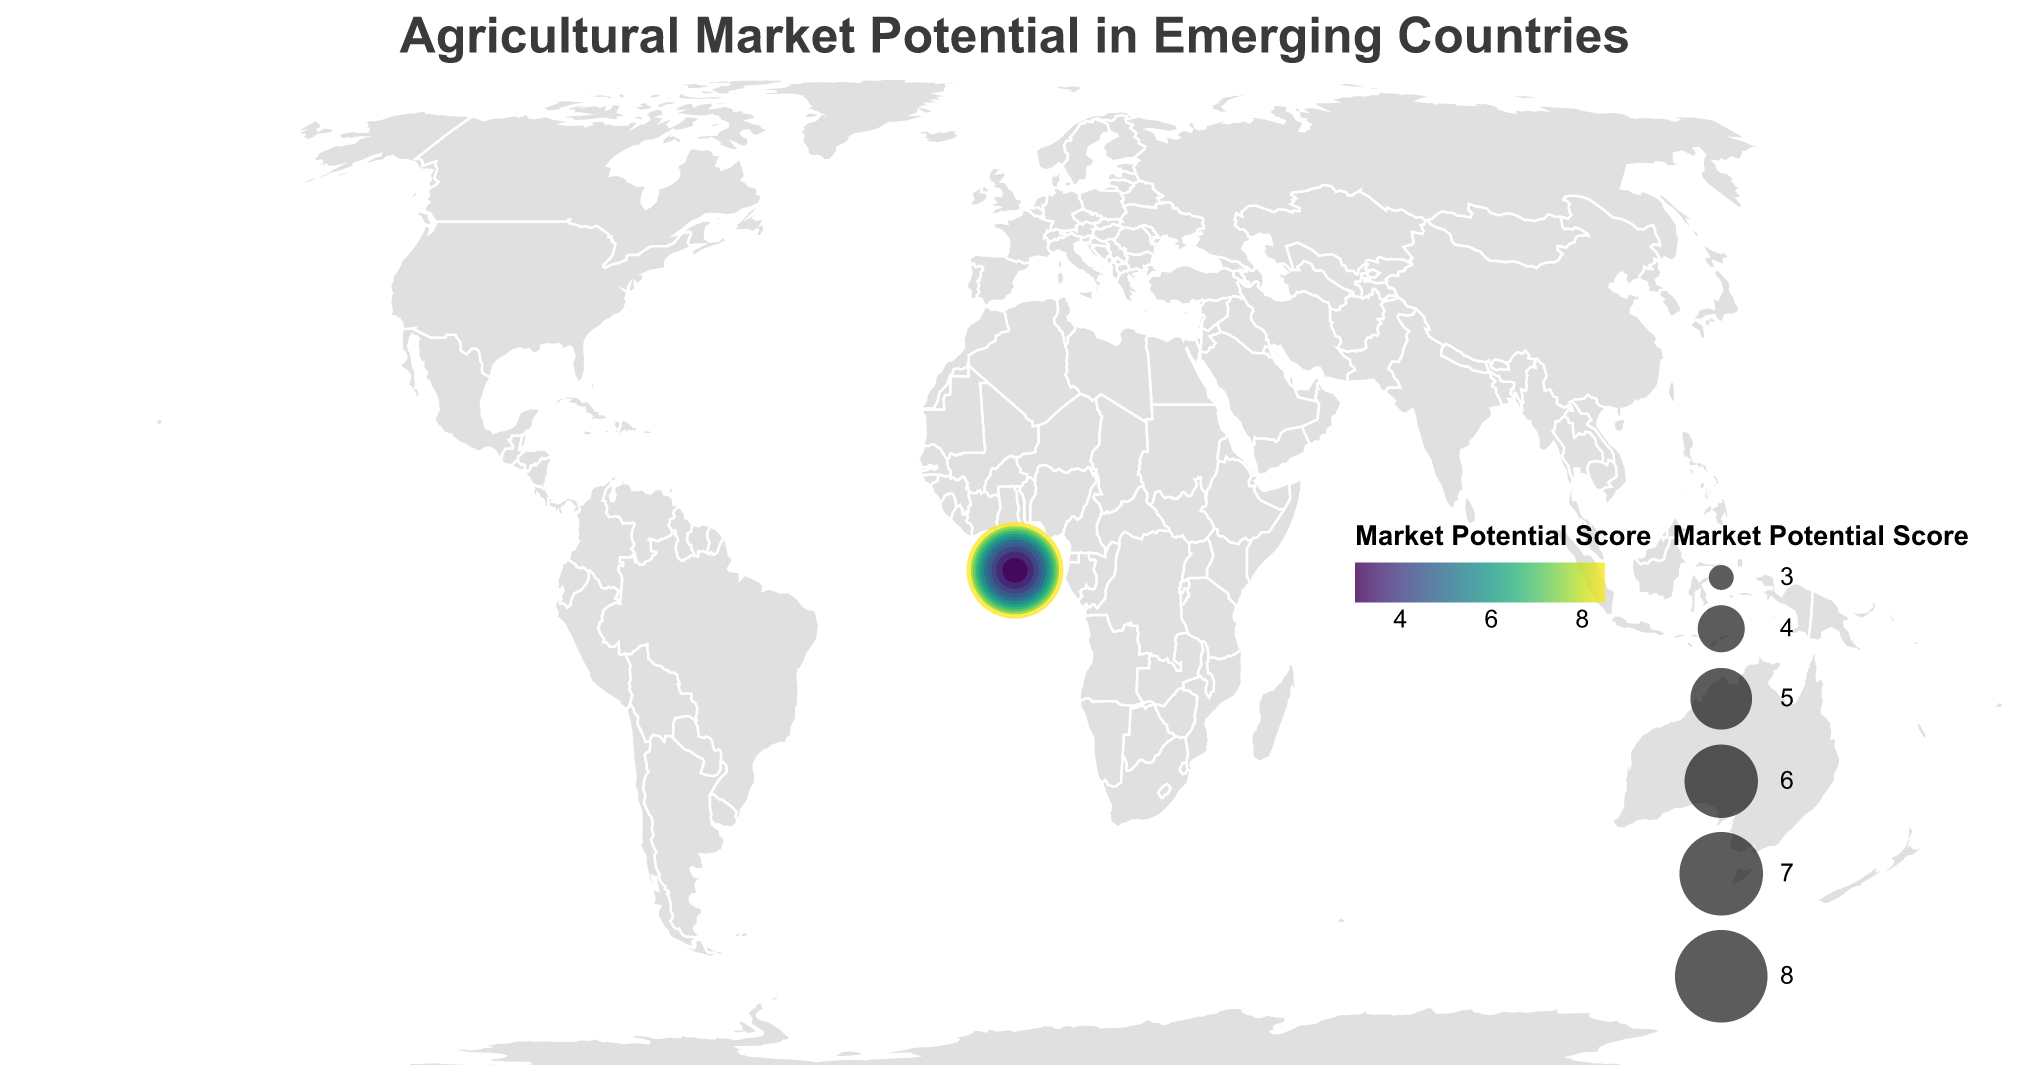What is the title of the figure? The title is usually displayed prominently at the top of the figure and provides a summary of what the figure is showing.
Answer: Agricultural Market Potential in Emerging Countries Which country has the highest Market Potential Score? To determine the country with the highest score, look at the size and color intensity of the circles, where the largest and darkest circle represents the highest score.
Answer: India What is the Market Potential Score for Brazil? Identify the circle that corresponds to Brazil and look at the tooltip or circle size and color to determine its score.
Answer: 6.0 Compare the Market Potential Scores of Vietnam and Indonesia. Which one is higher? By examining the size and color of the circles for Vietnam and Indonesia, you can compare their Market Potential Scores directly.
Answer: Indonesia (7.0) is higher than Vietnam (4.5) Which country has the fastest population growth? Look at the tooltips for each country to find the one with the highest percentage for Population Growth (%).
Answer: Nigeria What are the three countries with the highest Plant-based Protein Growth (%)? Check the tooltips for each country's Plant-based Protein Growth (%) and identify the top three values.
Answer: Brazil (5.0), India (4.5), Thailand (4.2) Calculate the average Market Potential Score for all countries shown. Sum all the Market Potential Scores and divide by the total number of countries (12). (8.5 + 7.5 + 7.0 + 6.5 + 6.0 + 5.5 + 5.0 + 5.0 + 4.5 + 4.0 + 3.5 + 3.0 = 66 / 12)
Answer: 5.5 Identify the country with the smallest Market Potential Score and list its key growth percentages. Find the country with the smallest circle and lowest color intensity, then examine its tooltip for the growth percentages.
Answer: South Africa: Population Growth (%) 1.2, Meat Consumption Growth (%) 0.5, Dairy Consumption Growth (%) 0.7, Plant-based Protein Growth (%) 3.0 Which country has the largest growth in Dairy Consumption (%)? Look for the highest Dairy Consumption Growth (%) value in the tooltips for each country.
Answer: India (3.0) Which country has a higher Plant-based Protein Growth (%), Mexico or Bangladesh? Compare the Plant-based Protein Growth (%) for Mexico and Bangladesh by checking their tooltips.
Answer: Mexico (3.8) 